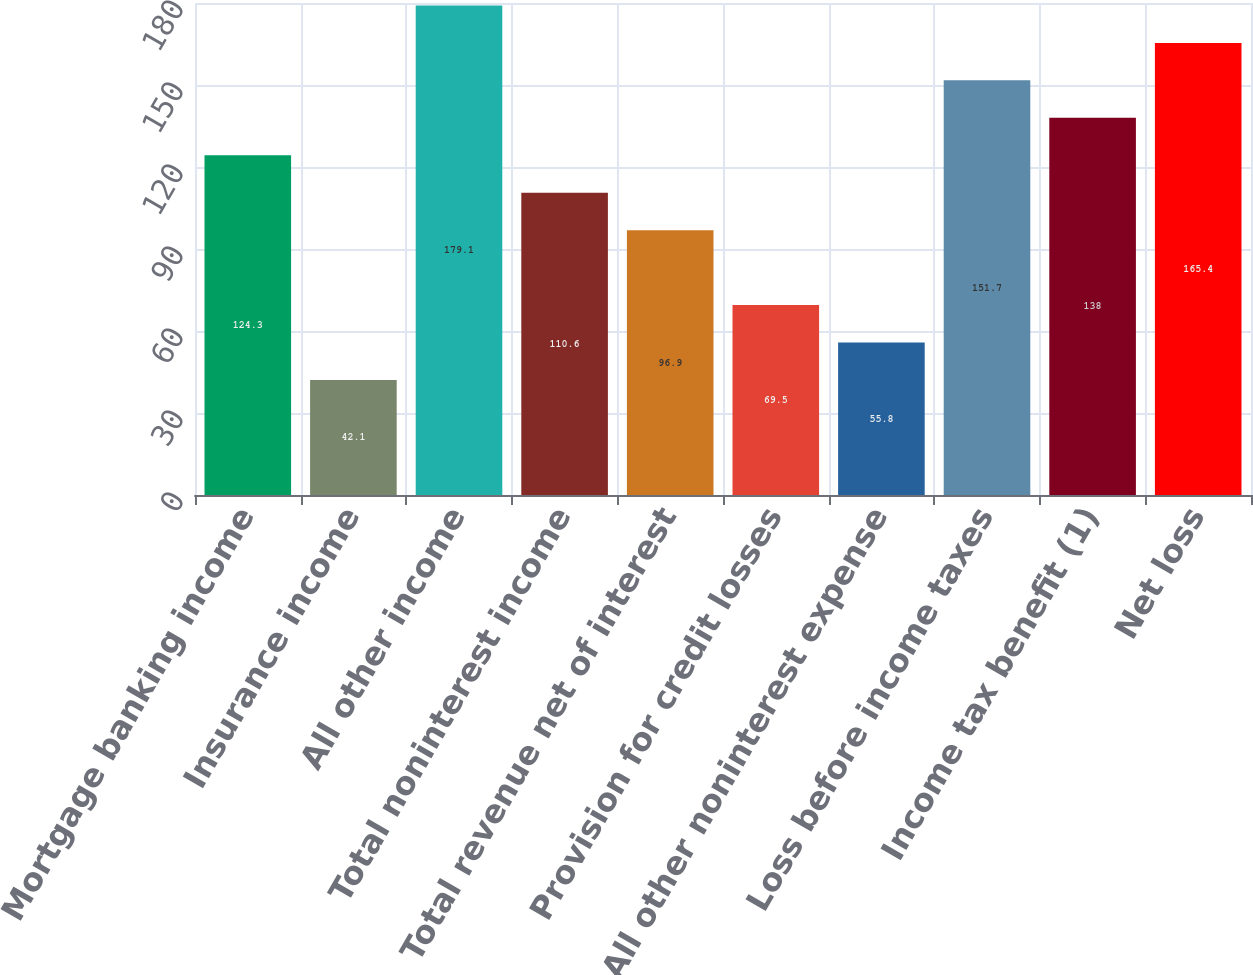Convert chart to OTSL. <chart><loc_0><loc_0><loc_500><loc_500><bar_chart><fcel>Mortgage banking income<fcel>Insurance income<fcel>All other income<fcel>Total noninterest income<fcel>Total revenue net of interest<fcel>Provision for credit losses<fcel>All other noninterest expense<fcel>Loss before income taxes<fcel>Income tax benefit (1)<fcel>Net loss<nl><fcel>124.3<fcel>42.1<fcel>179.1<fcel>110.6<fcel>96.9<fcel>69.5<fcel>55.8<fcel>151.7<fcel>138<fcel>165.4<nl></chart> 